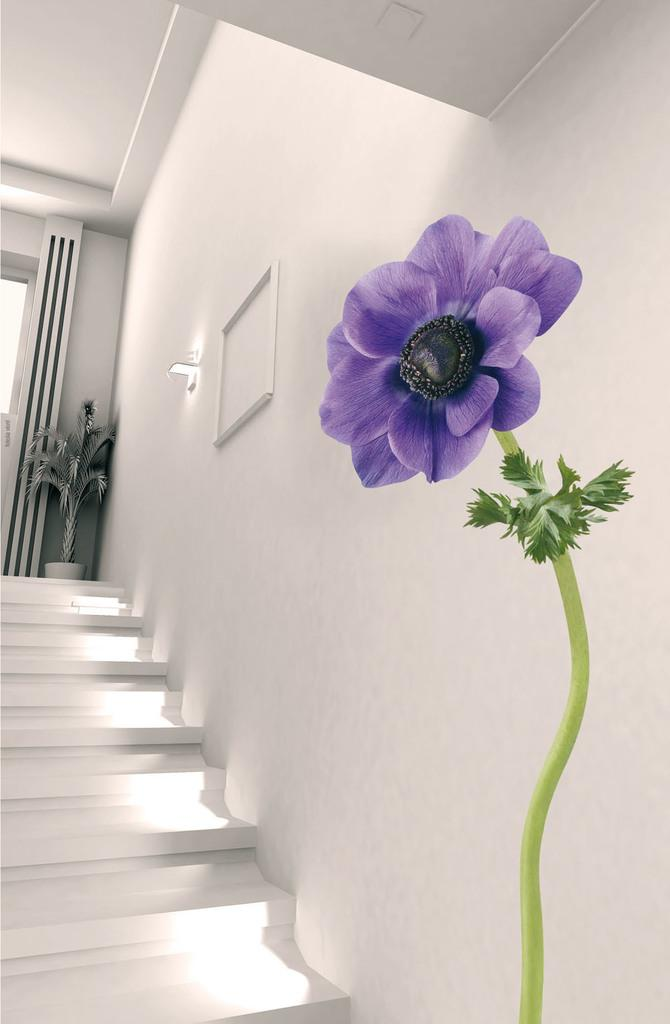What type of structure can be seen in the image? There are stairs in the image. Can you describe the lighting in the image? There is light in the middle of the image. How many goldfish are swimming in the light in the image? There are no goldfish present in the image; it only features stairs and light. What type of animals can be seen interacting with the maid in the image? There is no maid or any animals present in the image. 